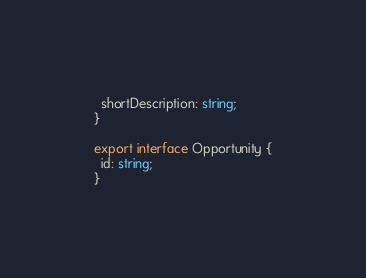Convert code to text. <code><loc_0><loc_0><loc_500><loc_500><_TypeScript_>  shortDescription: string;
}

export interface Opportunity {
  id: string;
}
</code> 